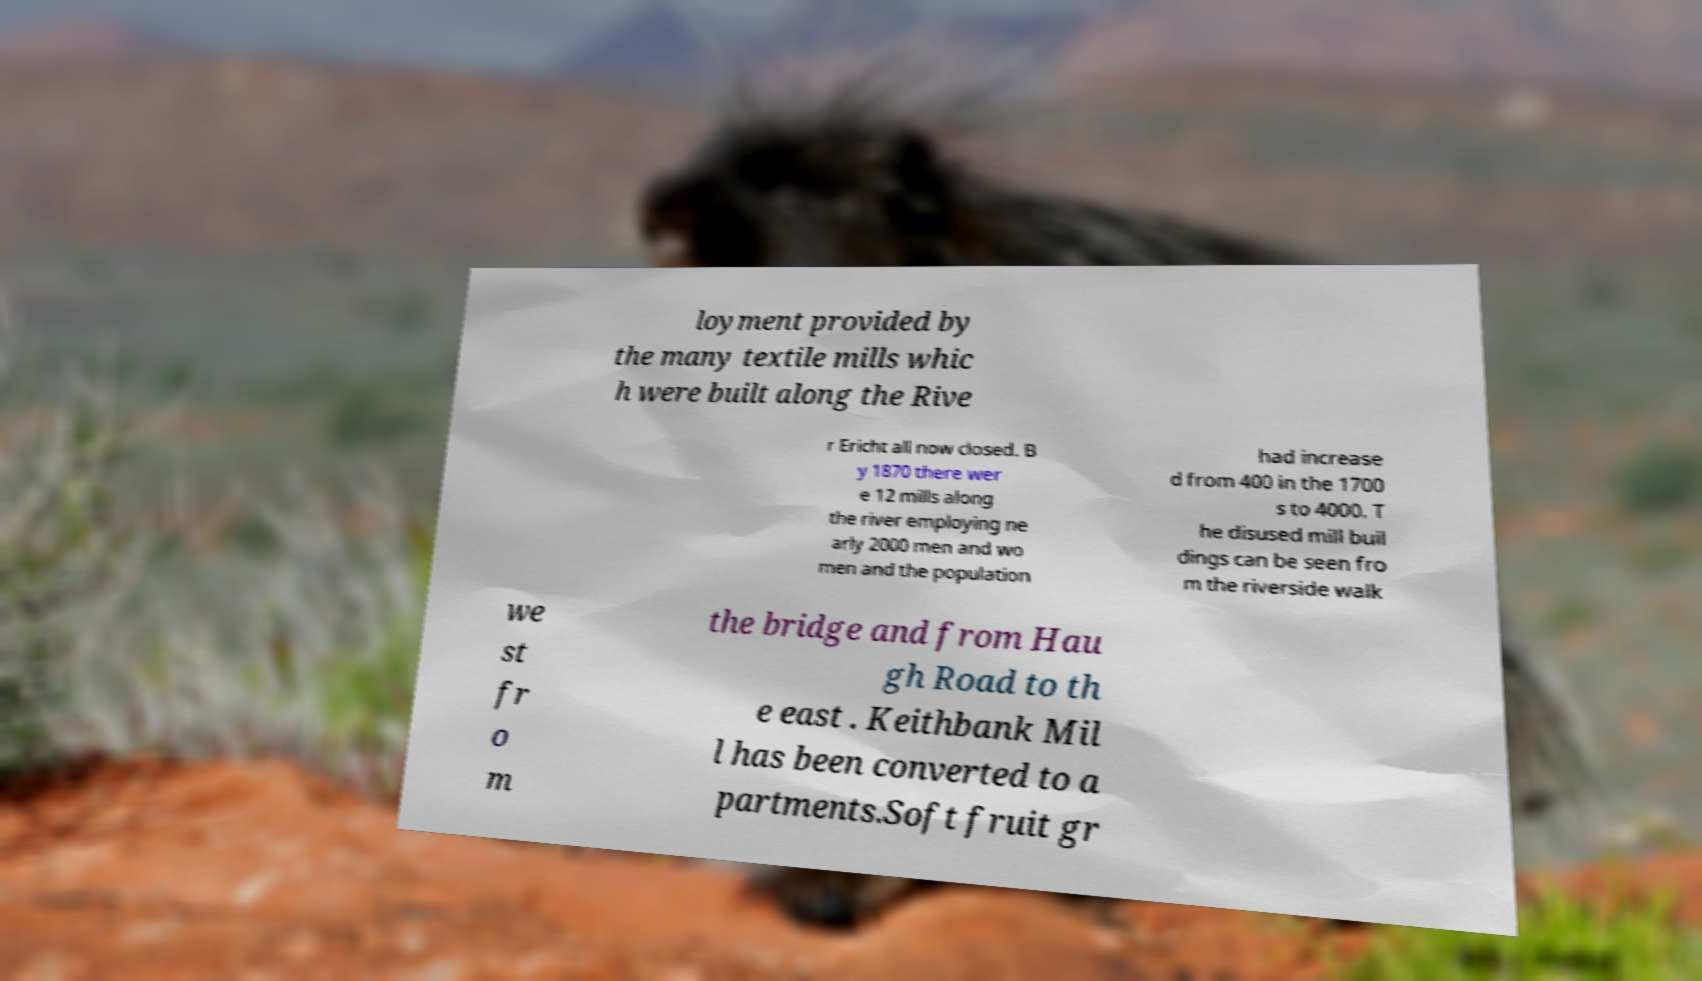I need the written content from this picture converted into text. Can you do that? loyment provided by the many textile mills whic h were built along the Rive r Ericht all now closed. B y 1870 there wer e 12 mills along the river employing ne arly 2000 men and wo men and the population had increase d from 400 in the 1700 s to 4000. T he disused mill buil dings can be seen fro m the riverside walk we st fr o m the bridge and from Hau gh Road to th e east . Keithbank Mil l has been converted to a partments.Soft fruit gr 